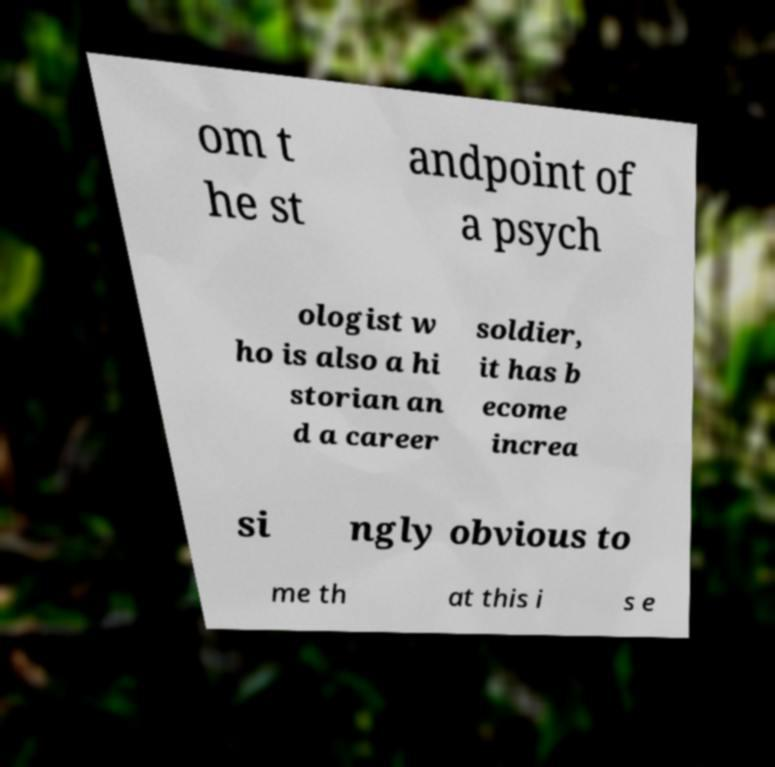Could you assist in decoding the text presented in this image and type it out clearly? om t he st andpoint of a psych ologist w ho is also a hi storian an d a career soldier, it has b ecome increa si ngly obvious to me th at this i s e 